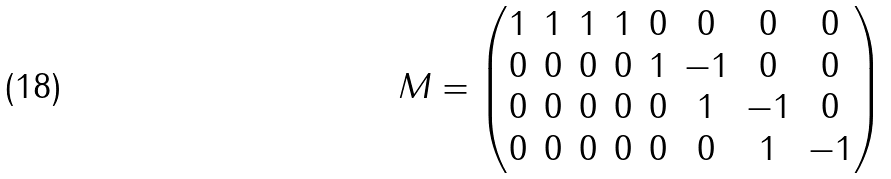Convert formula to latex. <formula><loc_0><loc_0><loc_500><loc_500>M = \begin{pmatrix} 1 & 1 & 1 & 1 & 0 & 0 & 0 & 0 \\ 0 & 0 & 0 & 0 & 1 & - 1 & 0 & 0 \\ 0 & 0 & 0 & 0 & 0 & 1 & - 1 & 0 \\ 0 & 0 & 0 & 0 & 0 & 0 & 1 & - 1 \\ \end{pmatrix}</formula> 